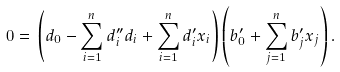<formula> <loc_0><loc_0><loc_500><loc_500>0 = & \ \left ( d _ { 0 } - \sum _ { i = 1 } ^ { n } d _ { i } ^ { \prime \prime } d _ { i } + \sum _ { i = 1 } ^ { n } d _ { i } ^ { \prime } x _ { i } \right ) \left ( b _ { 0 } ^ { \prime } + \sum _ { j = 1 } ^ { n } b _ { j } ^ { \prime } x _ { j } \right ) .</formula> 